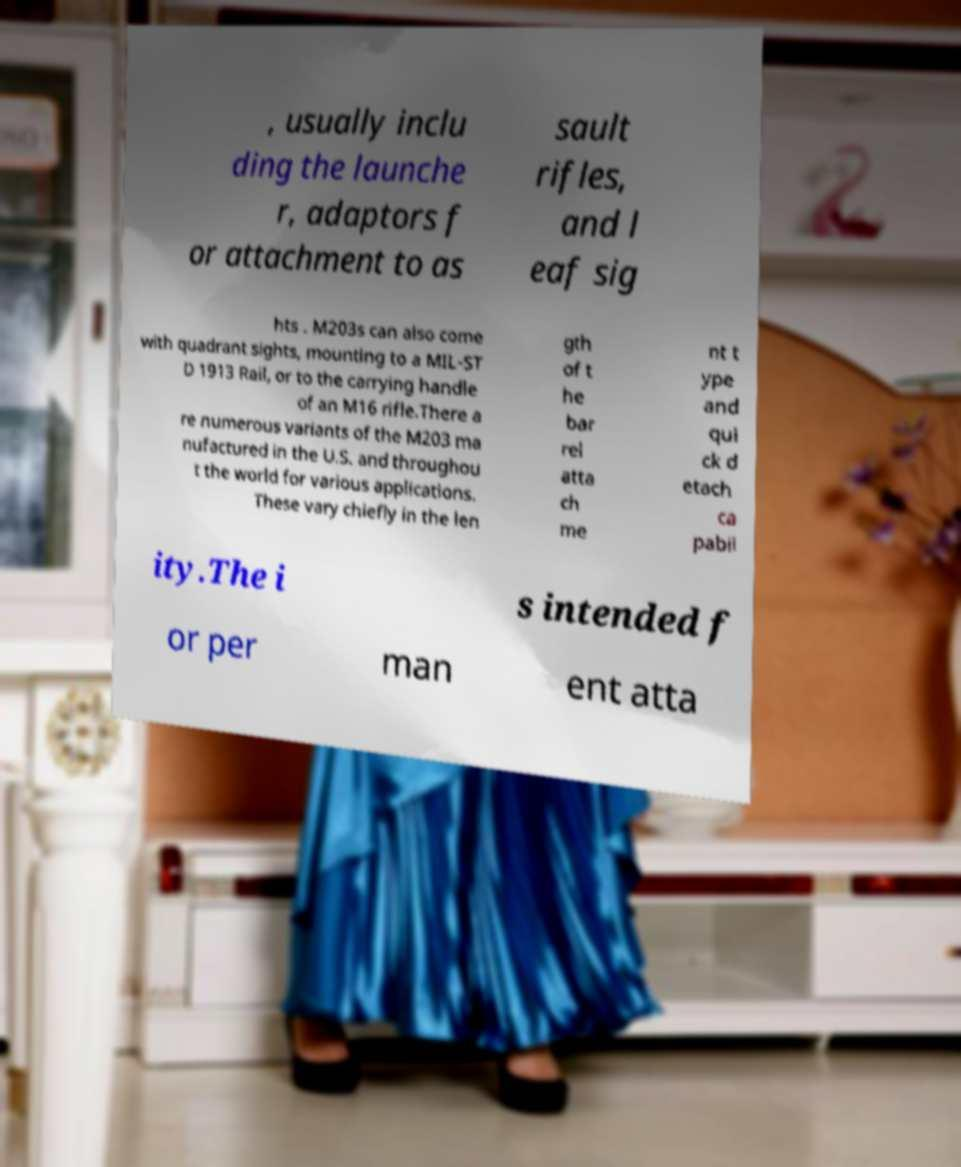What messages or text are displayed in this image? I need them in a readable, typed format. , usually inclu ding the launche r, adaptors f or attachment to as sault rifles, and l eaf sig hts . M203s can also come with quadrant sights, mounting to a MIL-ST D 1913 Rail, or to the carrying handle of an M16 rifle.There a re numerous variants of the M203 ma nufactured in the U.S. and throughou t the world for various applications. These vary chiefly in the len gth of t he bar rel atta ch me nt t ype and qui ck d etach ca pabil ity.The i s intended f or per man ent atta 